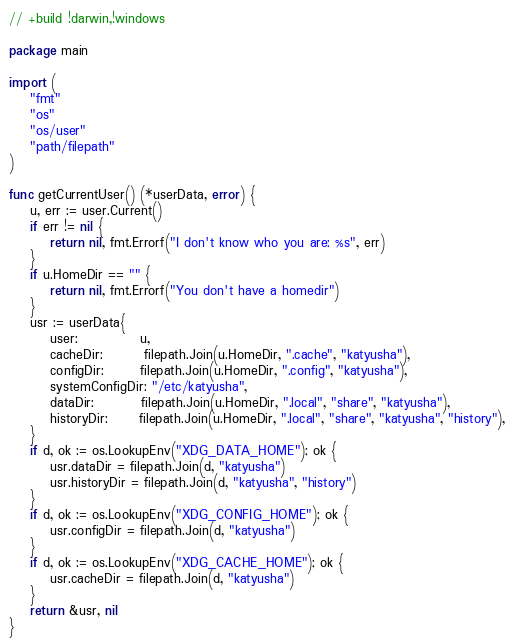Convert code to text. <code><loc_0><loc_0><loc_500><loc_500><_Go_>// +build !darwin,!windows

package main

import (
	"fmt"
	"os"
	"os/user"
	"path/filepath"
)

func getCurrentUser() (*userData, error) {
	u, err := user.Current()
	if err != nil {
		return nil, fmt.Errorf("I don't know who you are: %s", err)
	}
	if u.HomeDir == "" {
		return nil, fmt.Errorf("You don't have a homedir")
	}
	usr := userData{
		user:            u,
		cacheDir:        filepath.Join(u.HomeDir, ".cache", "katyusha"),
		configDir:       filepath.Join(u.HomeDir, ".config", "katyusha"),
		systemConfigDir: "/etc/katyusha",
		dataDir:         filepath.Join(u.HomeDir, ".local", "share", "katyusha"),
		historyDir:      filepath.Join(u.HomeDir, ".local", "share", "katyusha", "history"),
	}
	if d, ok := os.LookupEnv("XDG_DATA_HOME"); ok {
		usr.dataDir = filepath.Join(d, "katyusha")
		usr.historyDir = filepath.Join(d, "katyusha", "history")
	}
	if d, ok := os.LookupEnv("XDG_CONFIG_HOME"); ok {
		usr.configDir = filepath.Join(d, "katyusha")
	}
	if d, ok := os.LookupEnv("XDG_CACHE_HOME"); ok {
		usr.cacheDir = filepath.Join(d, "katyusha")
	}
	return &usr, nil
}
</code> 